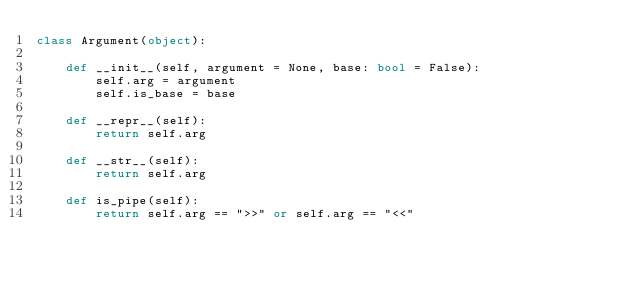<code> <loc_0><loc_0><loc_500><loc_500><_Python_>class Argument(object):

    def __init__(self, argument = None, base: bool = False):
        self.arg = argument
        self.is_base = base

    def __repr__(self):
        return self.arg

    def __str__(self):
        return self.arg

    def is_pipe(self):
        return self.arg == ">>" or self.arg == "<<"
</code> 